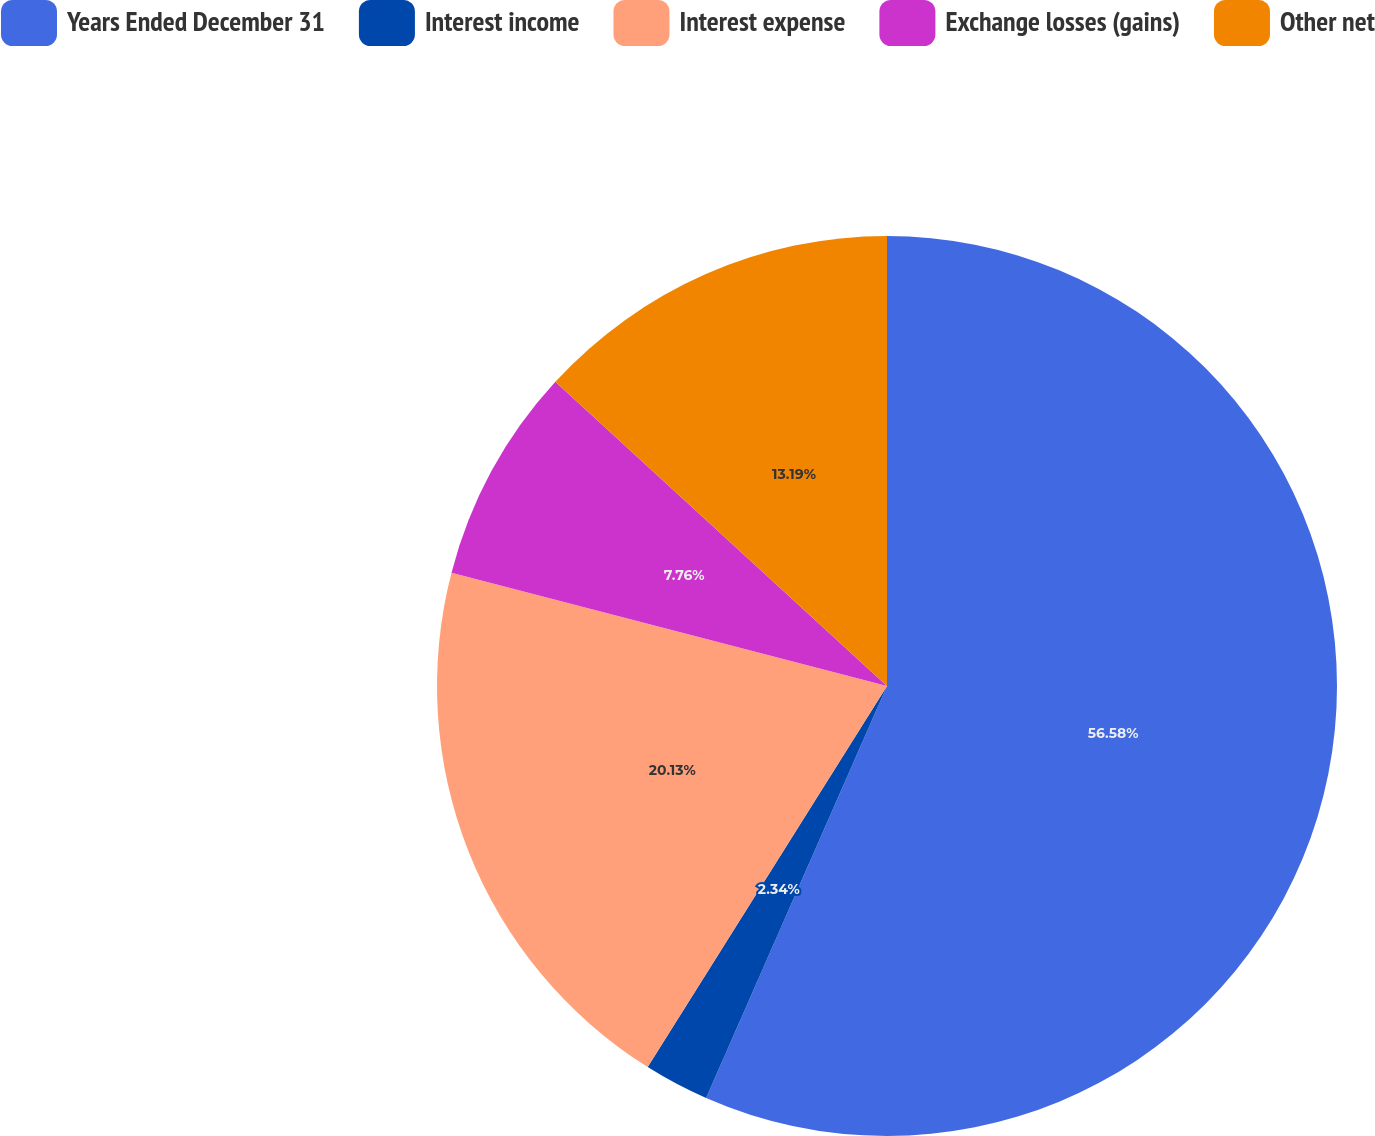Convert chart. <chart><loc_0><loc_0><loc_500><loc_500><pie_chart><fcel>Years Ended December 31<fcel>Interest income<fcel>Interest expense<fcel>Exchange losses (gains)<fcel>Other net<nl><fcel>56.59%<fcel>2.34%<fcel>20.13%<fcel>7.76%<fcel>13.19%<nl></chart> 